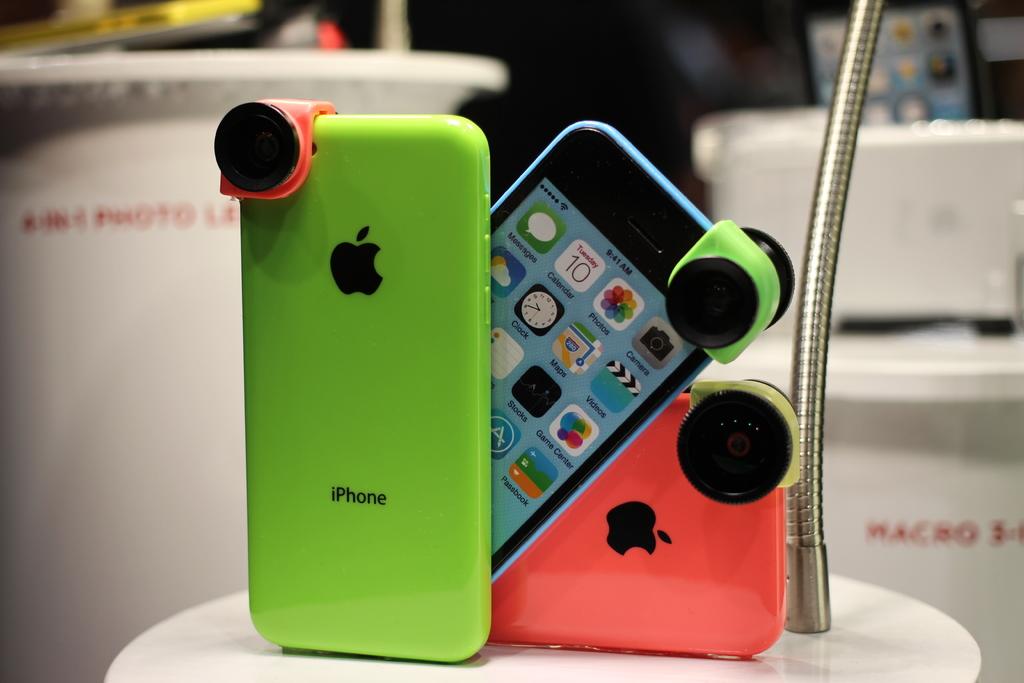What phone brand is this?
Keep it short and to the point. Iphone. 